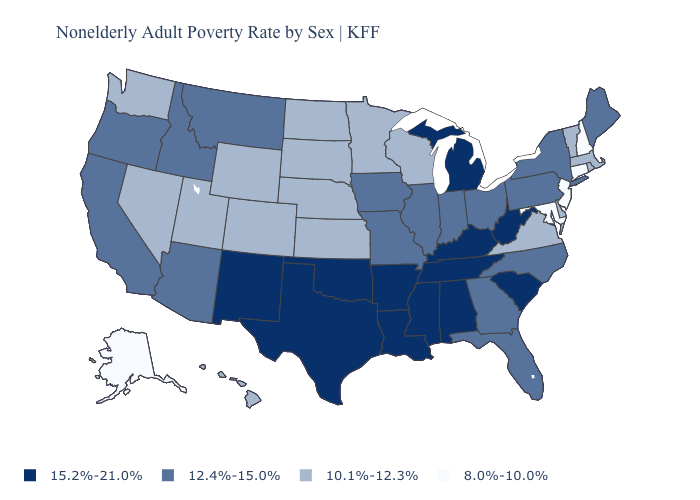Name the states that have a value in the range 12.4%-15.0%?
Quick response, please. Arizona, California, Florida, Georgia, Idaho, Illinois, Indiana, Iowa, Maine, Missouri, Montana, New York, North Carolina, Ohio, Oregon, Pennsylvania. What is the value of New York?
Concise answer only. 12.4%-15.0%. Among the states that border Oklahoma , does Arkansas have the highest value?
Be succinct. Yes. Is the legend a continuous bar?
Write a very short answer. No. What is the value of South Carolina?
Concise answer only. 15.2%-21.0%. Name the states that have a value in the range 8.0%-10.0%?
Keep it brief. Alaska, Connecticut, Maryland, New Hampshire, New Jersey. What is the value of Idaho?
Quick response, please. 12.4%-15.0%. What is the lowest value in the USA?
Short answer required. 8.0%-10.0%. Is the legend a continuous bar?
Answer briefly. No. Name the states that have a value in the range 8.0%-10.0%?
Quick response, please. Alaska, Connecticut, Maryland, New Hampshire, New Jersey. What is the value of New Hampshire?
Be succinct. 8.0%-10.0%. What is the value of West Virginia?
Answer briefly. 15.2%-21.0%. What is the lowest value in states that border Delaware?
Concise answer only. 8.0%-10.0%. What is the value of New York?
Write a very short answer. 12.4%-15.0%. Name the states that have a value in the range 10.1%-12.3%?
Answer briefly. Colorado, Delaware, Hawaii, Kansas, Massachusetts, Minnesota, Nebraska, Nevada, North Dakota, Rhode Island, South Dakota, Utah, Vermont, Virginia, Washington, Wisconsin, Wyoming. 